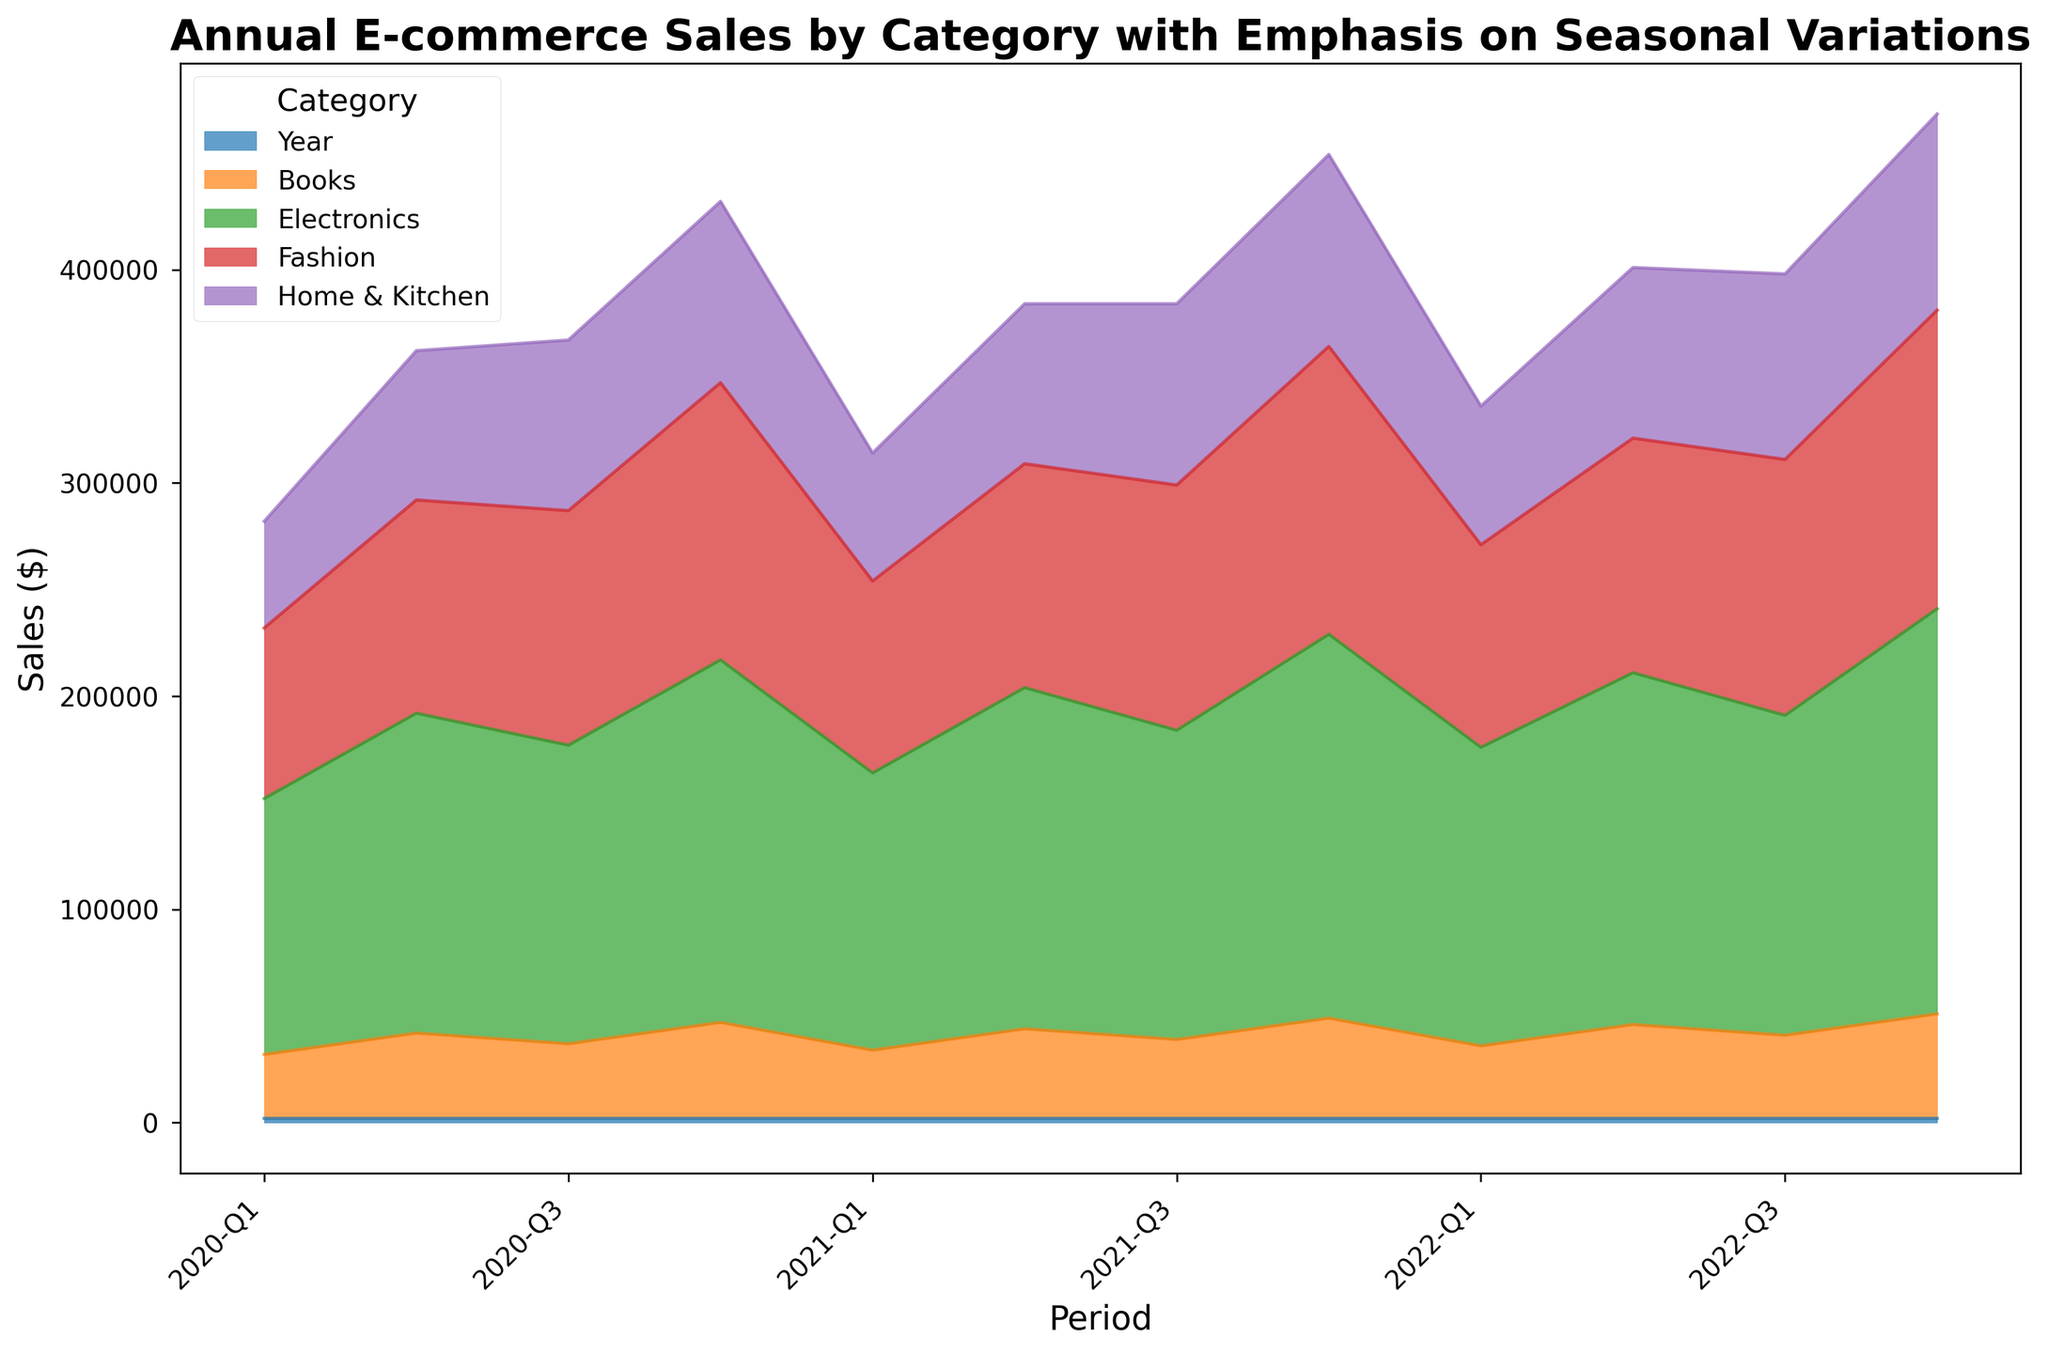What trend is observed in the sales of Electronics from Q1 to Q4 in 2020? The area chart shows the height of the Electronics segment growing significantly over the quarters in 2020, indicating an upward trend. From Q1 to Q4, sales of Electronics steadily increased from $120,000 to $170,000.
Answer: Sales increased from Q1 to Q4 in 2020 Which category had the highest sales in Q4 of 2022? By observing the height of the segments in Q4 2022, the Electronics category clearly has the tallest segment.
Answer: Electronics How did the sales of Books change from Q1 to Q4 in each year? By tracking the bottom-most segment in each year, Books sales showed a gradual increase from Q1 to Q4. In 2020: $30,000 to $45,000, in 2021: $32,000 to $47,000, and in 2022: $34,000 to $49,000.
Answer: Increased in each year What is the combined sales of Fashion and Home & Kitchen in Q2 across all years? Summing the heights for each segment in Q2 across three years: 2020: 100,000 + 70,000 = 170,000, 2021: 105,000 + 75,000 = 180,000, 2022: 110,000 + 80,000 = 190,000. Total: 170,000 + 180,000 + 190,000 = 540,000
Answer: $540,000 Between Fashion and Electronics, which one shows a more consistent upward trend from Q1 to Q4 across all years? By observing the segments’ heights for each category, Electronics show a more consistent and visible increase each Q4 compared to Fashion, which has both increases and smaller fluctuations.
Answer: Electronics What is the percentage increase in Fashion sales from Q1 2020 to Q4 2022? Q1 2020 Fashion sales were $80,000. Q4 2022 was $140,000. The percentage increase is calculated as ((140,000 - 80,000) / 80,000) * 100 = 75%.
Answer: 75% Among all categories, which has the smallest overall sales growth between Q4 2020 and Q4 2022? Observe each category's segment growth from Q4 2020 to Q4 2022. Books grew from $45,000 to $49,000, which is the smallest growth.
Answer: Books Which year experienced the highest total sales in Q4 among all categories combined? Adding up the segments' heights in Q4 for each year: 2020: 170,000 + 130,000 + 85,000 + 45,000 = 430,000, 2021: 180,000 + 135,000 + 90,000 + 47,000 = 452,000, and 2022: 190,000 + 140,000 + 92,000 + 49,000 = 471,000. The highest is 2022 with $471,000.
Answer: 2022 